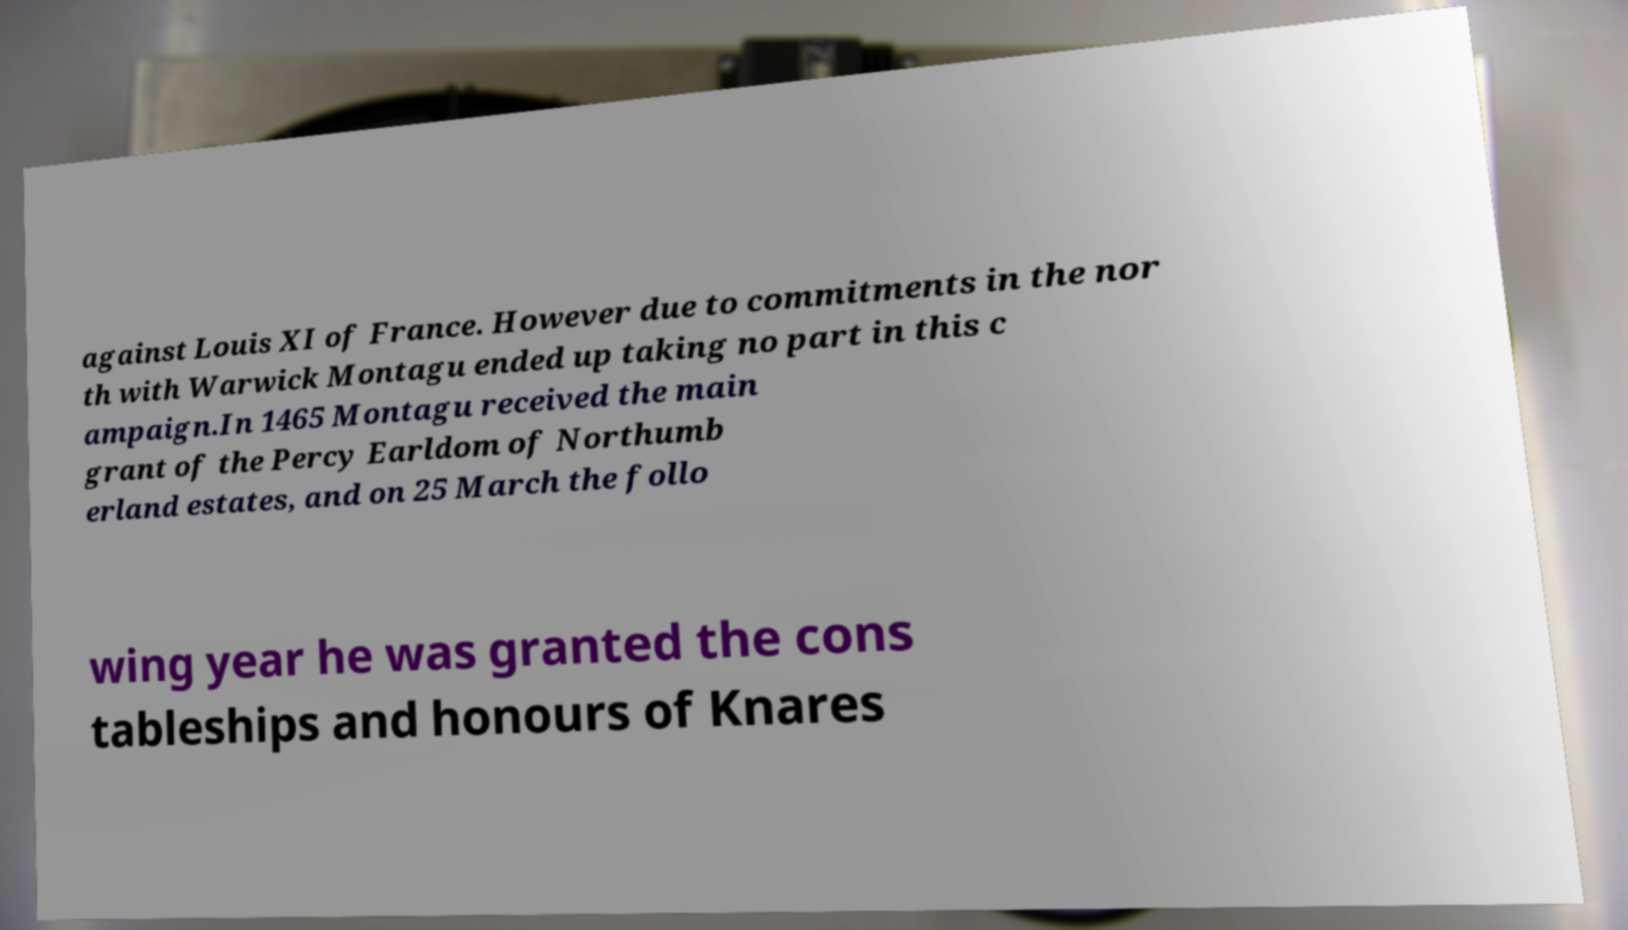There's text embedded in this image that I need extracted. Can you transcribe it verbatim? against Louis XI of France. However due to commitments in the nor th with Warwick Montagu ended up taking no part in this c ampaign.In 1465 Montagu received the main grant of the Percy Earldom of Northumb erland estates, and on 25 March the follo wing year he was granted the cons tableships and honours of Knares 